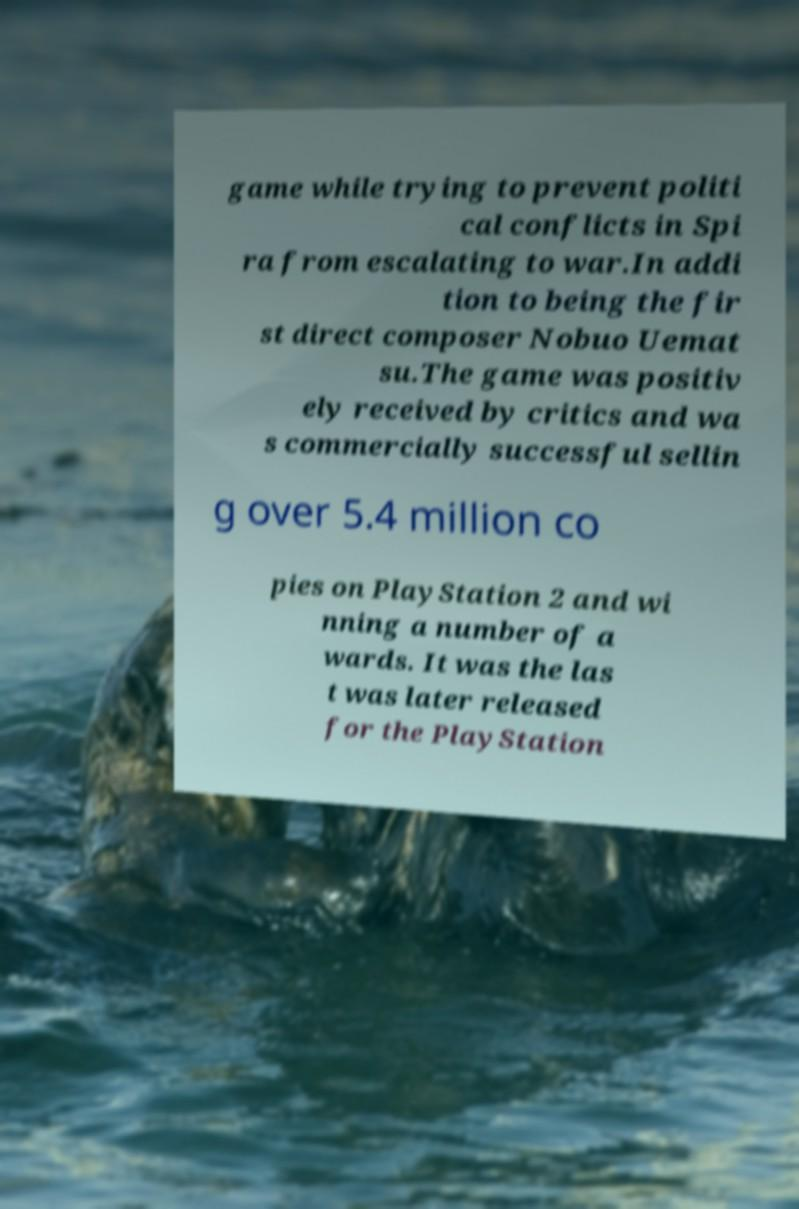For documentation purposes, I need the text within this image transcribed. Could you provide that? game while trying to prevent politi cal conflicts in Spi ra from escalating to war.In addi tion to being the fir st direct composer Nobuo Uemat su.The game was positiv ely received by critics and wa s commercially successful sellin g over 5.4 million co pies on PlayStation 2 and wi nning a number of a wards. It was the las t was later released for the PlayStation 